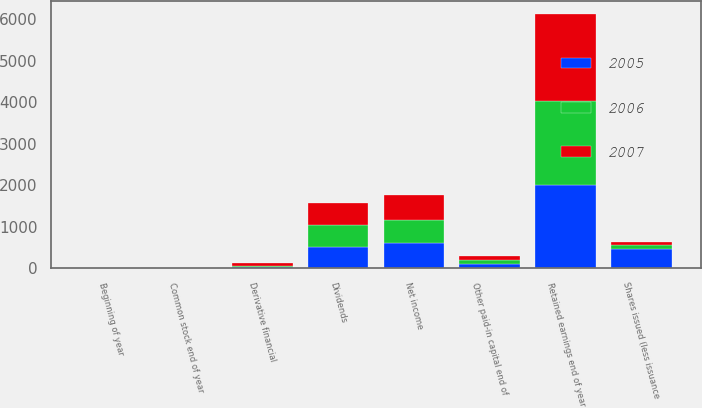<chart> <loc_0><loc_0><loc_500><loc_500><stacked_bar_chart><ecel><fcel>Beginning of year<fcel>Common stock end of year<fcel>Shares issued (less issuance<fcel>Other paid-in capital end of<fcel>Net income<fcel>Dividends<fcel>Retained earnings end of year<fcel>Derivative financial<nl><fcel>2007<fcel>2<fcel>2<fcel>91<fcel>96<fcel>618<fcel>527<fcel>2110<fcel>60<nl><fcel>2006<fcel>2<fcel>2<fcel>96<fcel>96<fcel>547<fcel>522<fcel>2024<fcel>40<nl><fcel>2005<fcel>2<fcel>2<fcel>454<fcel>96<fcel>606<fcel>511<fcel>1999<fcel>17<nl></chart> 